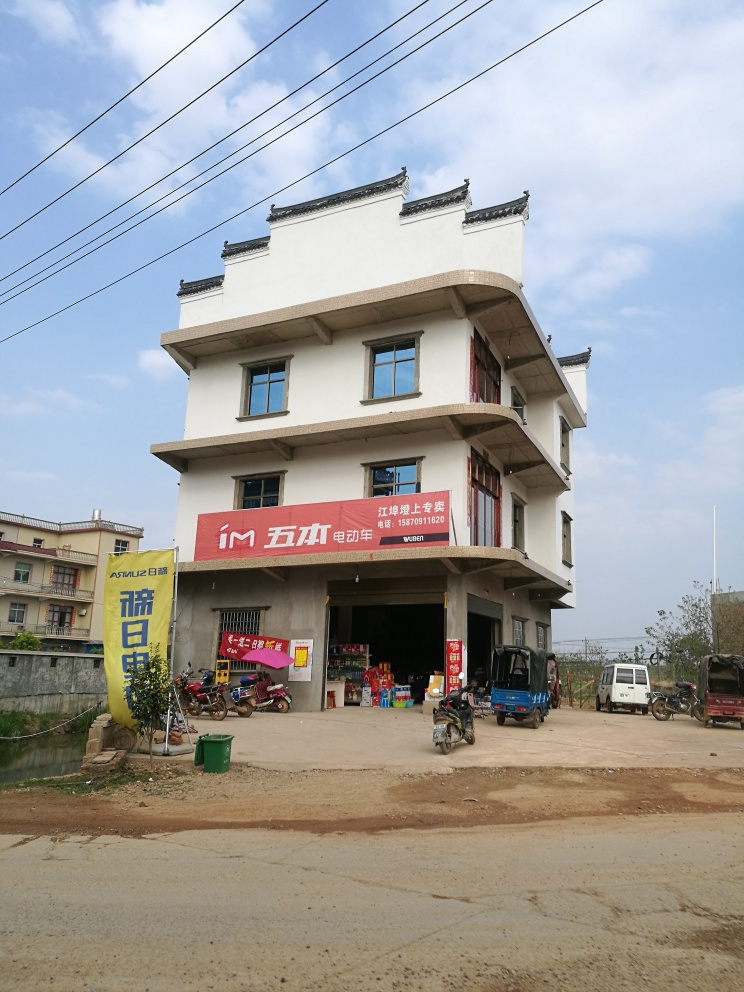Are there any focus issues in the image?
A. No
B. Yes
Answer with the option's letter from the given choices directly.
 A. 